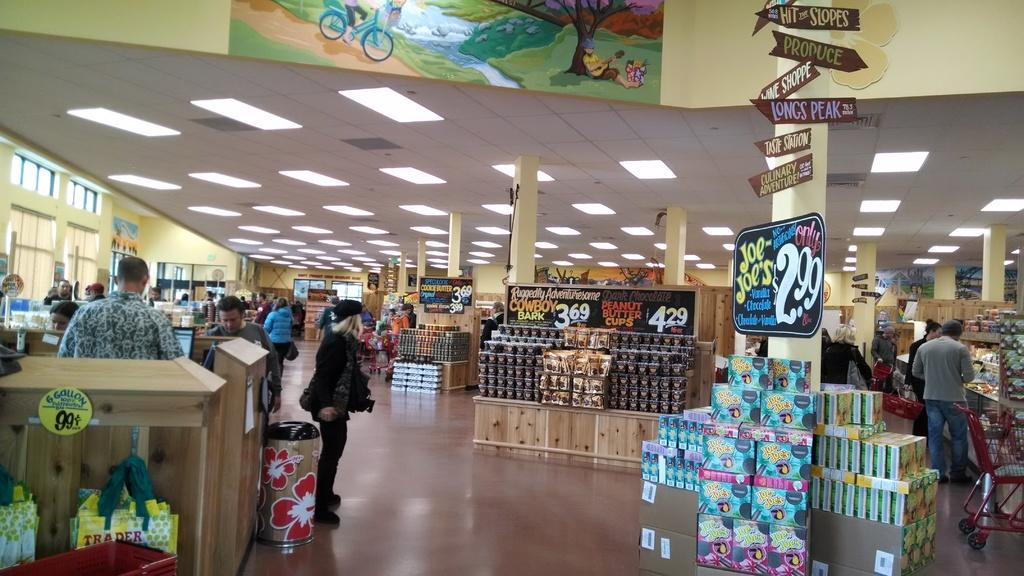<image>
Present a compact description of the photo's key features. The interiror of a shop that sells Joe Joes candy and peanut butter cups amongst other goodies 